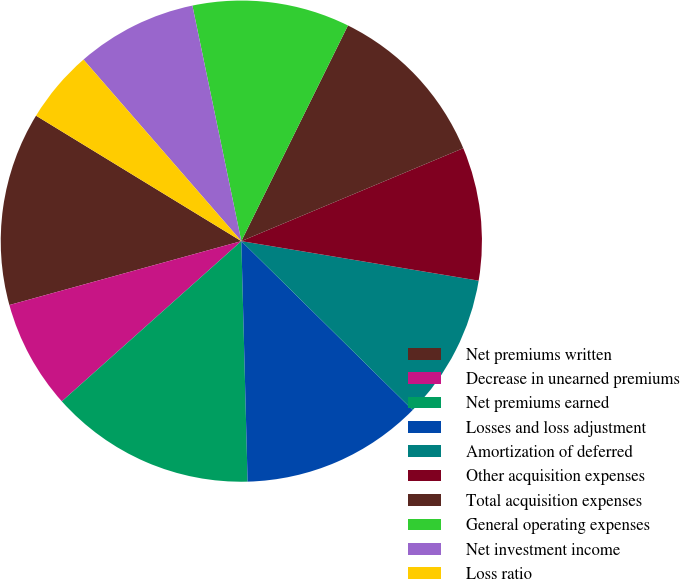<chart> <loc_0><loc_0><loc_500><loc_500><pie_chart><fcel>Net premiums written<fcel>Decrease in unearned premiums<fcel>Net premiums earned<fcel>Losses and loss adjustment<fcel>Amortization of deferred<fcel>Other acquisition expenses<fcel>Total acquisition expenses<fcel>General operating expenses<fcel>Net investment income<fcel>Loss ratio<nl><fcel>13.01%<fcel>7.32%<fcel>13.82%<fcel>12.2%<fcel>9.76%<fcel>8.94%<fcel>11.38%<fcel>10.57%<fcel>8.13%<fcel>4.88%<nl></chart> 